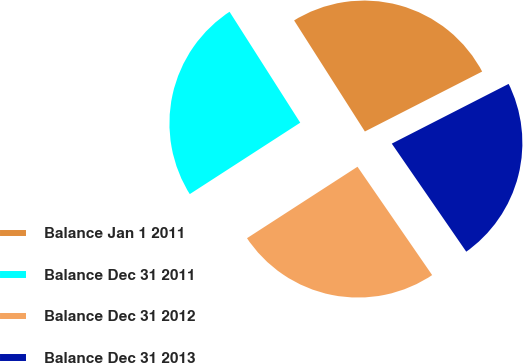<chart> <loc_0><loc_0><loc_500><loc_500><pie_chart><fcel>Balance Jan 1 2011<fcel>Balance Dec 31 2011<fcel>Balance Dec 31 2012<fcel>Balance Dec 31 2013<nl><fcel>26.51%<fcel>25.11%<fcel>25.47%<fcel>22.92%<nl></chart> 